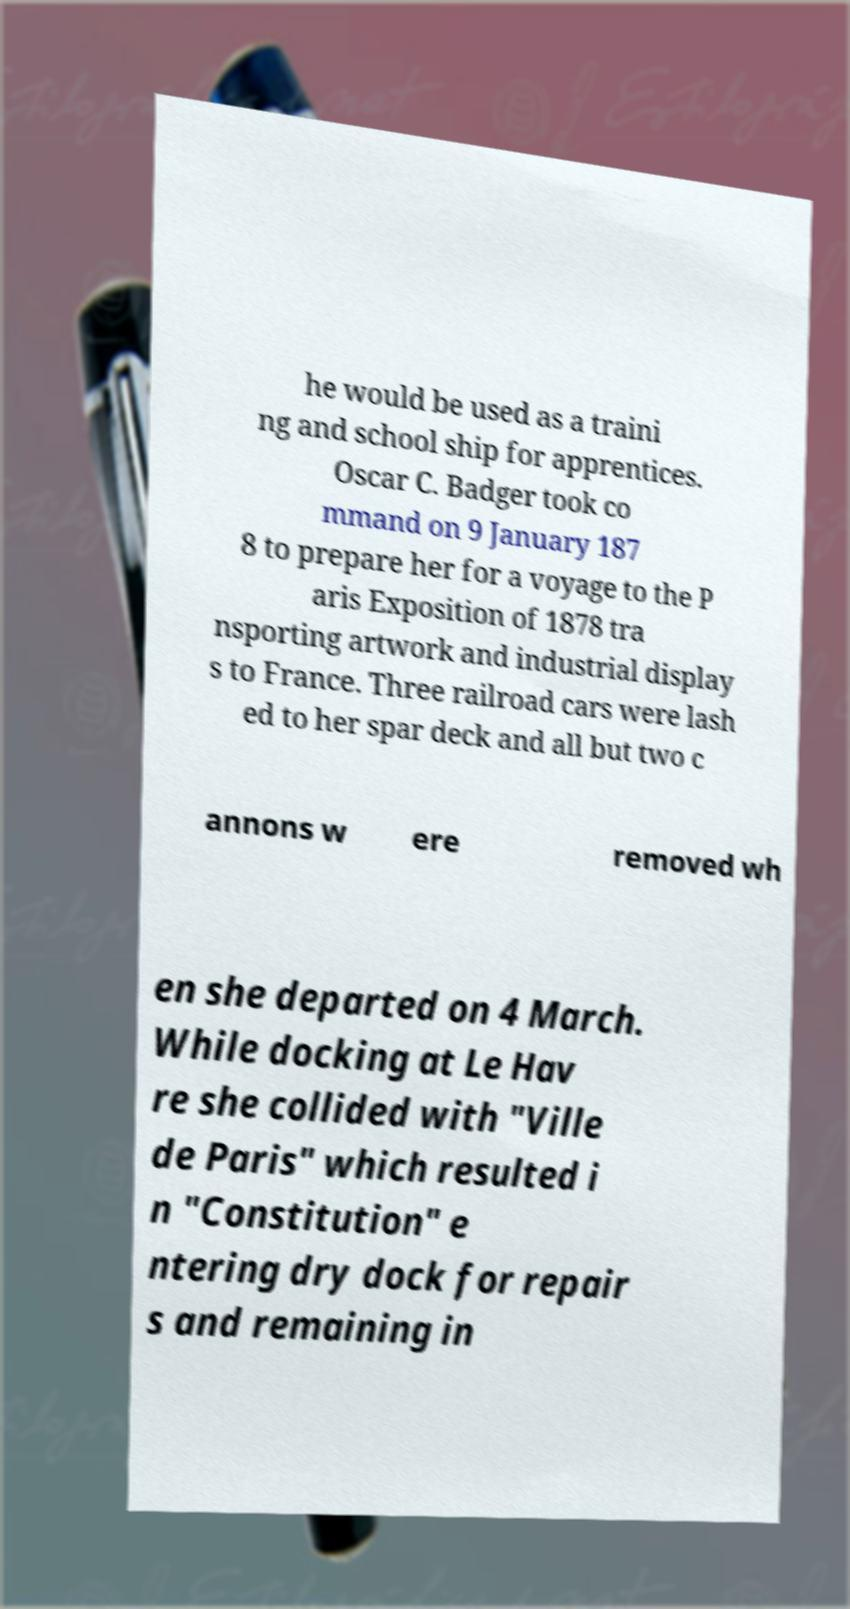What messages or text are displayed in this image? I need them in a readable, typed format. he would be used as a traini ng and school ship for apprentices. Oscar C. Badger took co mmand on 9 January 187 8 to prepare her for a voyage to the P aris Exposition of 1878 tra nsporting artwork and industrial display s to France. Three railroad cars were lash ed to her spar deck and all but two c annons w ere removed wh en she departed on 4 March. While docking at Le Hav re she collided with "Ville de Paris" which resulted i n "Constitution" e ntering dry dock for repair s and remaining in 